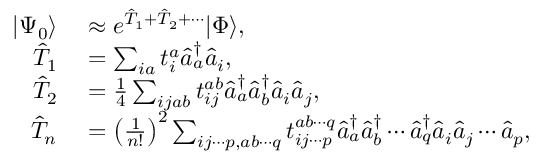<formula> <loc_0><loc_0><loc_500><loc_500>\begin{array} { r l } { | \Psi _ { 0 } \rangle } & \approx e ^ { \hat { T } _ { 1 } + \hat { T } _ { 2 } + \cdots } | \Phi \rangle , } \\ { \hat { T } _ { 1 } } & = \sum _ { i a } t _ { i } ^ { a } \hat { a } _ { a } ^ { \dagger } \hat { a } _ { i } , } \\ { \hat { T } _ { 2 } } & = \frac { 1 } { 4 } \sum _ { i j a b } t _ { i j } ^ { a b } \hat { a } _ { a } ^ { \dagger } \hat { a } _ { b } ^ { \dagger } \hat { a } _ { i } \hat { a } _ { j } , } \\ { \hat { T } _ { n } } & = \left ( \frac { 1 } { n ! } \right ) ^ { 2 } \sum _ { i j \cdots p , a b \cdots q } t _ { i j \cdots p } ^ { a b \cdots q } \hat { a } _ { a } ^ { \dagger } \hat { a } _ { b } ^ { \dagger } \cdots \hat { a } _ { q } ^ { \dagger } \hat { a } _ { i } \hat { a } _ { j } \cdots \hat { a } _ { p } , } \end{array}</formula> 